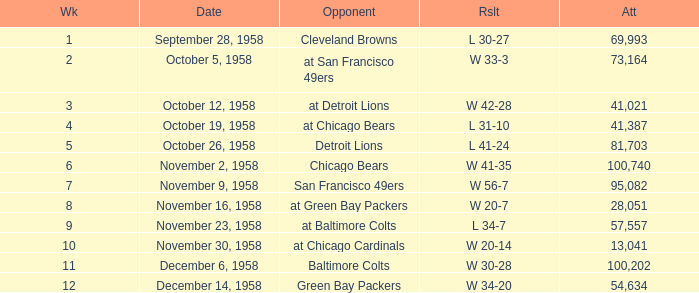What was the higest attendance on November 9, 1958? 95082.0. 